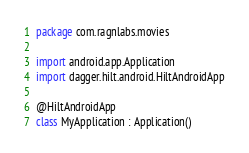Convert code to text. <code><loc_0><loc_0><loc_500><loc_500><_Kotlin_>package com.ragnlabs.movies

import android.app.Application
import dagger.hilt.android.HiltAndroidApp

@HiltAndroidApp
class MyApplication : Application()
</code> 